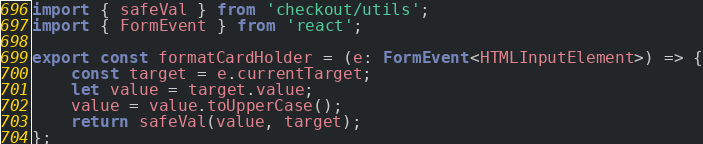Convert code to text. <code><loc_0><loc_0><loc_500><loc_500><_TypeScript_>import { safeVal } from 'checkout/utils';
import { FormEvent } from 'react';

export const formatCardHolder = (e: FormEvent<HTMLInputElement>) => {
    const target = e.currentTarget;
    let value = target.value;
    value = value.toUpperCase();
    return safeVal(value, target);
};
</code> 